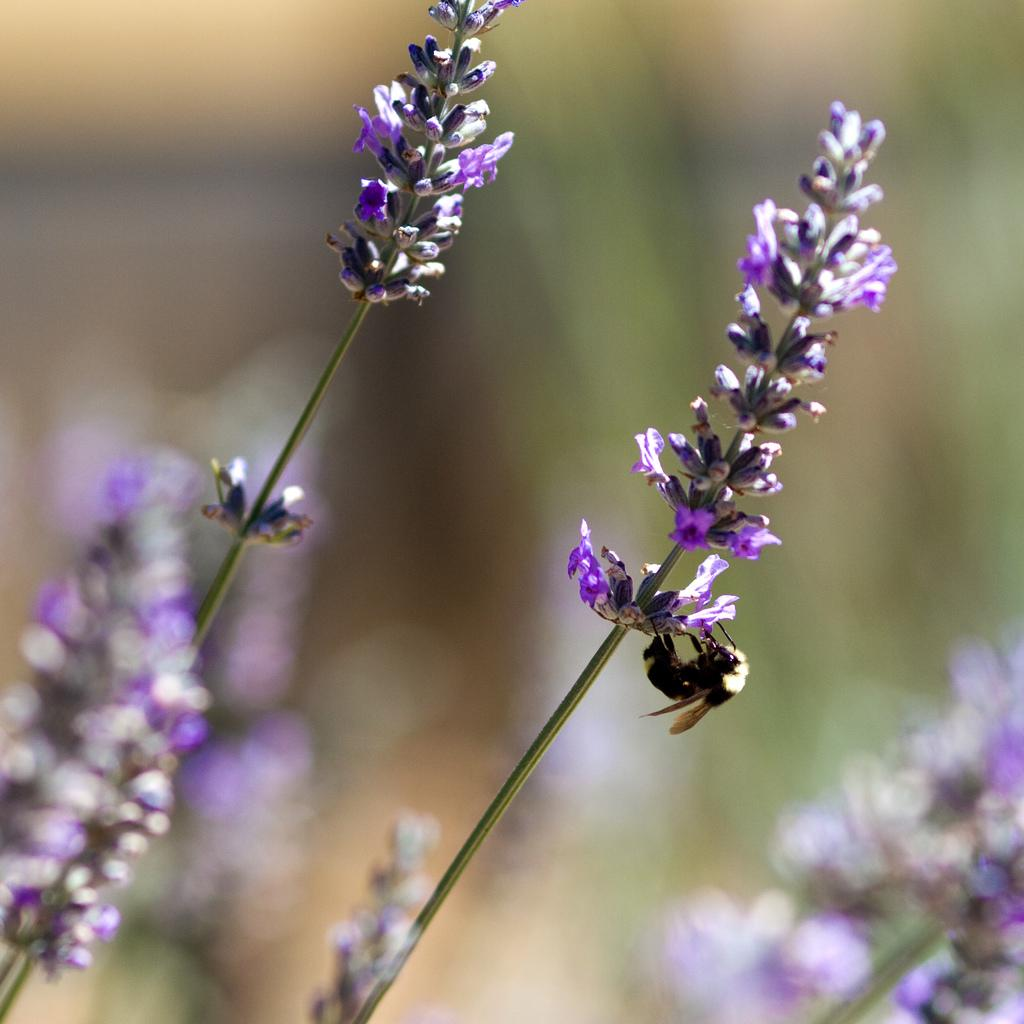What is the main subject of the image? The main subject of the image is small flowers. Where are the flowers located in the image? The small flowers are in the middle of the image. What type of paper is used to make the quilt in the image? There is no quilt present in the image, and therefore no paper or quilt can be observed. 